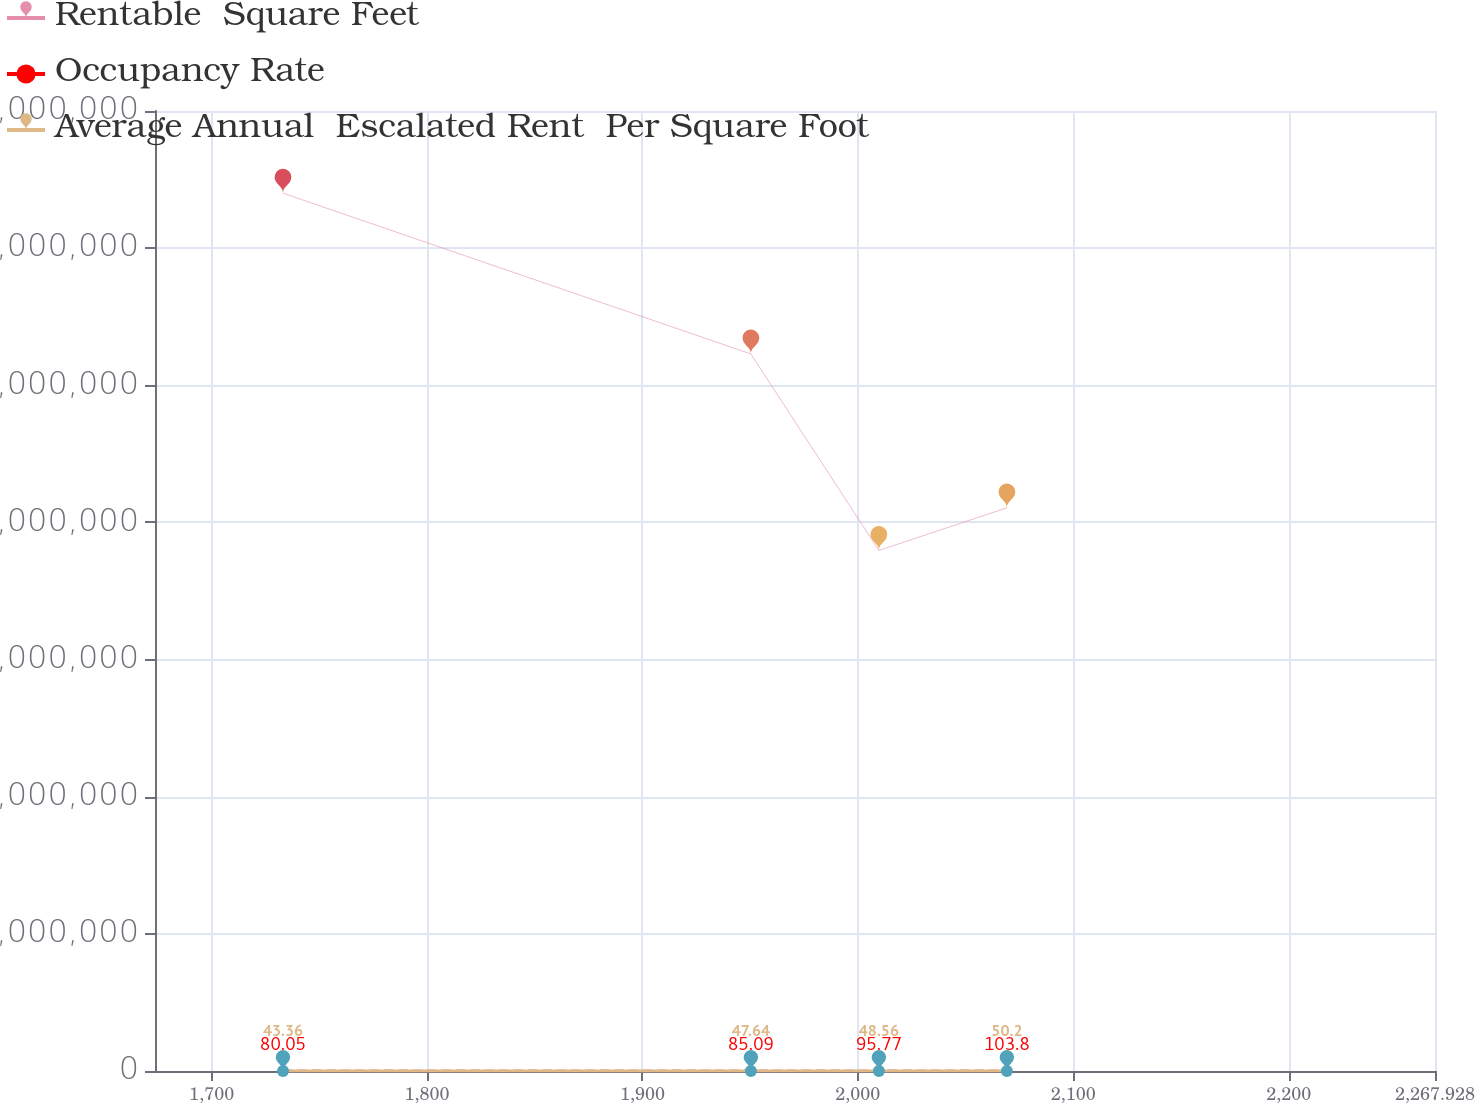Convert chart to OTSL. <chart><loc_0><loc_0><loc_500><loc_500><line_chart><ecel><fcel>Rentable  Square Feet<fcel>Occupancy Rate<fcel>Average Annual  Escalated Rent  Per Square Foot<nl><fcel>1733.13<fcel>1.92019e+07<fcel>80.05<fcel>43.36<nl><fcel>1950.35<fcel>1.56857e+07<fcel>85.09<fcel>47.64<nl><fcel>2009.77<fcel>1.13872e+07<fcel>95.77<fcel>48.56<nl><fcel>2069.19<fcel>1.23195e+07<fcel>103.8<fcel>50.2<nl><fcel>2327.35<fcel>1.31009e+07<fcel>101.47<fcel>40.98<nl></chart> 